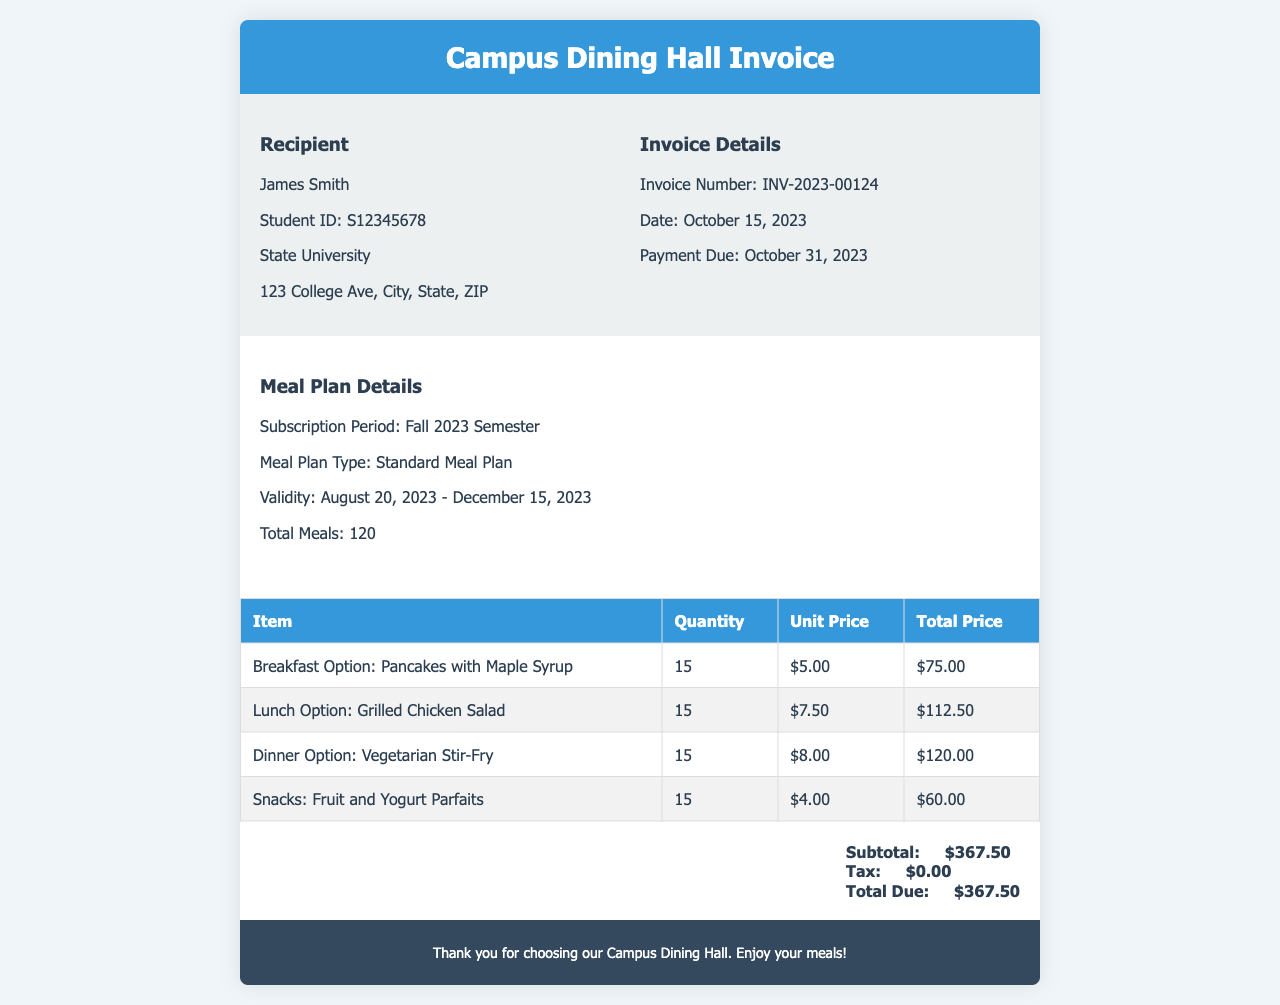What is the invoice number? The invoice number is stated in the invoice details section which specifies the unique identification number for this invoice.
Answer: INV-2023-00124 Who is the recipient of the invoice? The recipient's name is mentioned in the first section of the invoice, providing a clear indication of who the invoice is directed to.
Answer: James Smith What is the total amount due? The total amount due is calculated and displayed at the bottom of the invoice, representing the final charge after tax.
Answer: $367.50 How many meals are included in the meal plan? The total number of meals is provided in the meal plan details section, indicating how many meals the plan encompasses for the semester.
Answer: 120 What is the validity period of the meal plan? The validity period specifies the start and end dates of the meal plan which is mentioned in the meal plan details.
Answer: August 20, 2023 - December 15, 2023 What is the unit price of the lunch option? The invoice provides itemized charges, and the unit price specifically for the lunch option can be found in the itemized table of meal options.
Answer: $7.50 What is the total price for the breakfast option? The total price is summed up for the breakfast option based on the quantity and unit price detailed in the invoice table.
Answer: $75.00 When is the payment due? The payment due date is stated in the invoice details section, indicating the date by which payment must be made.
Answer: October 31, 2023 